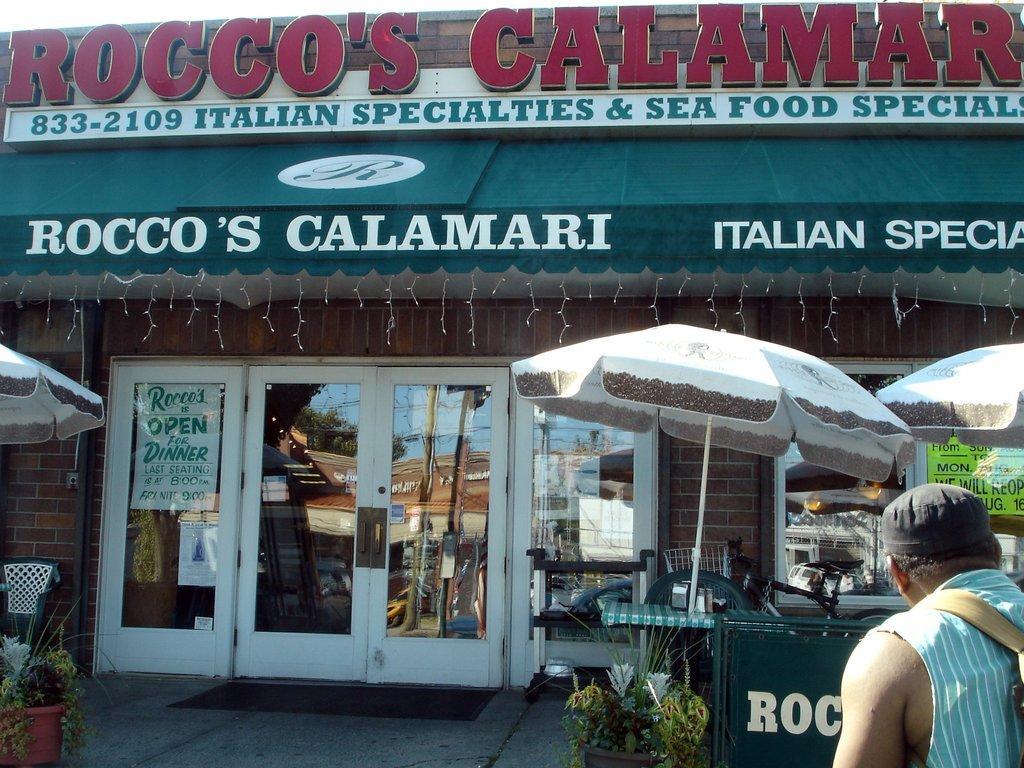How would you summarize this image in a sentence or two? In the image we can see there is a person standing and he is wearing cap. In front of him there is a shop and on the top of the shop there is a banner. 